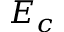<formula> <loc_0><loc_0><loc_500><loc_500>E _ { c }</formula> 